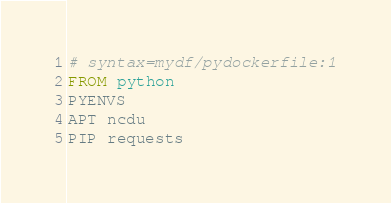Convert code to text. <code><loc_0><loc_0><loc_500><loc_500><_Dockerfile_># syntax=mydf/pydockerfile:1
FROM python
PYENVS
APT ncdu
PIP requests
</code> 